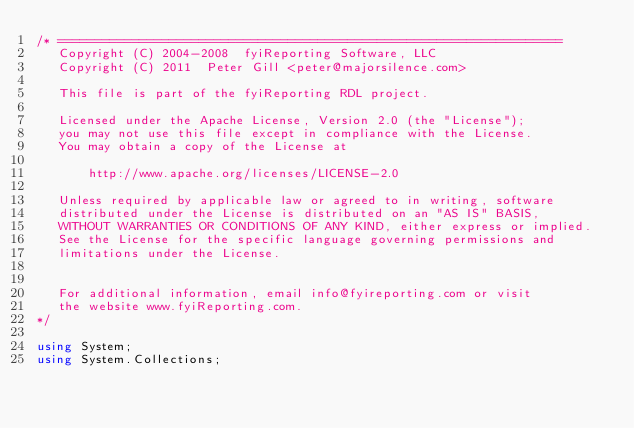<code> <loc_0><loc_0><loc_500><loc_500><_C#_>/* ====================================================================
   Copyright (C) 2004-2008  fyiReporting Software, LLC
   Copyright (C) 2011  Peter Gill <peter@majorsilence.com>

   This file is part of the fyiReporting RDL project.
	
   Licensed under the Apache License, Version 2.0 (the "License");
   you may not use this file except in compliance with the License.
   You may obtain a copy of the License at

       http://www.apache.org/licenses/LICENSE-2.0

   Unless required by applicable law or agreed to in writing, software
   distributed under the License is distributed on an "AS IS" BASIS,
   WITHOUT WARRANTIES OR CONDITIONS OF ANY KIND, either express or implied.
   See the License for the specific language governing permissions and
   limitations under the License.


   For additional information, email info@fyireporting.com or visit
   the website www.fyiReporting.com.
*/

using System;
using System.Collections;</code> 